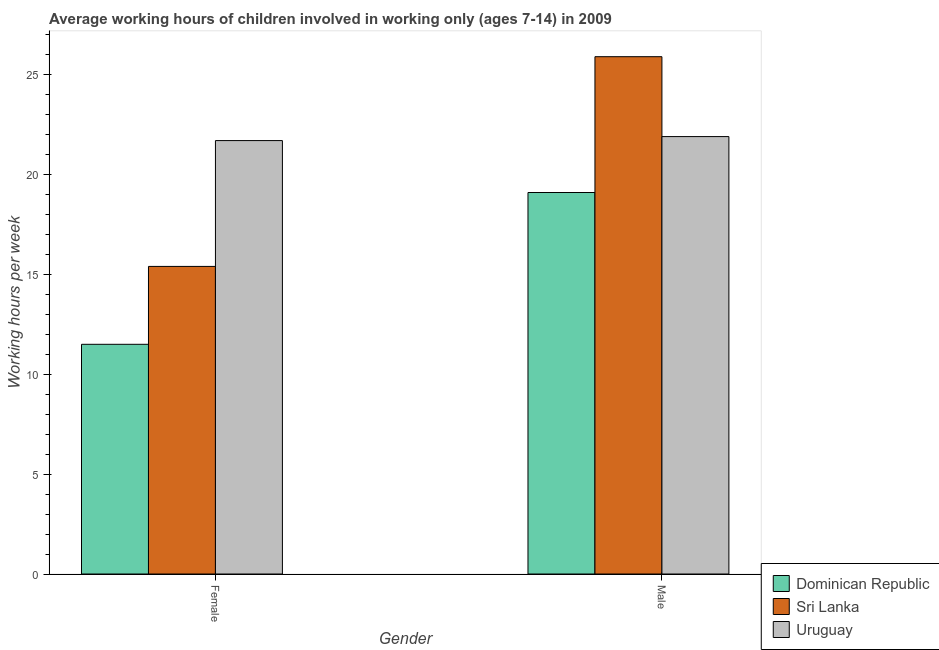How many different coloured bars are there?
Your answer should be very brief. 3. How many groups of bars are there?
Make the answer very short. 2. Are the number of bars per tick equal to the number of legend labels?
Make the answer very short. Yes. How many bars are there on the 1st tick from the right?
Offer a terse response. 3. What is the label of the 2nd group of bars from the left?
Give a very brief answer. Male. Across all countries, what is the maximum average working hour of male children?
Your response must be concise. 25.9. In which country was the average working hour of female children maximum?
Offer a terse response. Uruguay. In which country was the average working hour of male children minimum?
Give a very brief answer. Dominican Republic. What is the total average working hour of male children in the graph?
Provide a succinct answer. 66.9. What is the difference between the average working hour of male children in Uruguay and that in Sri Lanka?
Make the answer very short. -4. What is the difference between the average working hour of female children in Sri Lanka and the average working hour of male children in Uruguay?
Offer a terse response. -6.5. What is the average average working hour of male children per country?
Keep it short and to the point. 22.3. What is the difference between the average working hour of female children and average working hour of male children in Dominican Republic?
Make the answer very short. -7.6. In how many countries, is the average working hour of male children greater than 15 hours?
Offer a very short reply. 3. What is the ratio of the average working hour of female children in Uruguay to that in Sri Lanka?
Provide a succinct answer. 1.41. Is the average working hour of male children in Uruguay less than that in Dominican Republic?
Offer a terse response. No. What does the 3rd bar from the left in Female represents?
Your answer should be very brief. Uruguay. What does the 2nd bar from the right in Female represents?
Offer a very short reply. Sri Lanka. How many bars are there?
Make the answer very short. 6. How many countries are there in the graph?
Your answer should be very brief. 3. What is the difference between two consecutive major ticks on the Y-axis?
Keep it short and to the point. 5. Are the values on the major ticks of Y-axis written in scientific E-notation?
Provide a short and direct response. No. Does the graph contain grids?
Keep it short and to the point. No. Where does the legend appear in the graph?
Make the answer very short. Bottom right. How many legend labels are there?
Your answer should be compact. 3. How are the legend labels stacked?
Your answer should be compact. Vertical. What is the title of the graph?
Your answer should be very brief. Average working hours of children involved in working only (ages 7-14) in 2009. What is the label or title of the Y-axis?
Ensure brevity in your answer.  Working hours per week. What is the Working hours per week in Dominican Republic in Female?
Make the answer very short. 11.5. What is the Working hours per week of Sri Lanka in Female?
Offer a very short reply. 15.4. What is the Working hours per week of Uruguay in Female?
Provide a short and direct response. 21.7. What is the Working hours per week of Dominican Republic in Male?
Your answer should be compact. 19.1. What is the Working hours per week in Sri Lanka in Male?
Offer a very short reply. 25.9. What is the Working hours per week in Uruguay in Male?
Your answer should be compact. 21.9. Across all Gender, what is the maximum Working hours per week of Dominican Republic?
Offer a very short reply. 19.1. Across all Gender, what is the maximum Working hours per week in Sri Lanka?
Offer a very short reply. 25.9. Across all Gender, what is the maximum Working hours per week in Uruguay?
Your response must be concise. 21.9. Across all Gender, what is the minimum Working hours per week of Sri Lanka?
Your response must be concise. 15.4. Across all Gender, what is the minimum Working hours per week in Uruguay?
Make the answer very short. 21.7. What is the total Working hours per week in Dominican Republic in the graph?
Provide a short and direct response. 30.6. What is the total Working hours per week of Sri Lanka in the graph?
Offer a very short reply. 41.3. What is the total Working hours per week of Uruguay in the graph?
Offer a very short reply. 43.6. What is the difference between the Working hours per week in Dominican Republic in Female and that in Male?
Provide a short and direct response. -7.6. What is the difference between the Working hours per week in Sri Lanka in Female and that in Male?
Provide a succinct answer. -10.5. What is the difference between the Working hours per week of Dominican Republic in Female and the Working hours per week of Sri Lanka in Male?
Your response must be concise. -14.4. What is the difference between the Working hours per week of Dominican Republic in Female and the Working hours per week of Uruguay in Male?
Offer a very short reply. -10.4. What is the average Working hours per week of Dominican Republic per Gender?
Provide a short and direct response. 15.3. What is the average Working hours per week of Sri Lanka per Gender?
Offer a terse response. 20.65. What is the average Working hours per week of Uruguay per Gender?
Make the answer very short. 21.8. What is the difference between the Working hours per week of Dominican Republic and Working hours per week of Uruguay in Female?
Your answer should be compact. -10.2. What is the difference between the Working hours per week in Sri Lanka and Working hours per week in Uruguay in Female?
Provide a short and direct response. -6.3. What is the difference between the Working hours per week in Dominican Republic and Working hours per week in Sri Lanka in Male?
Offer a very short reply. -6.8. What is the difference between the Working hours per week of Dominican Republic and Working hours per week of Uruguay in Male?
Ensure brevity in your answer.  -2.8. What is the difference between the Working hours per week in Sri Lanka and Working hours per week in Uruguay in Male?
Your response must be concise. 4. What is the ratio of the Working hours per week in Dominican Republic in Female to that in Male?
Your answer should be compact. 0.6. What is the ratio of the Working hours per week of Sri Lanka in Female to that in Male?
Ensure brevity in your answer.  0.59. What is the ratio of the Working hours per week in Uruguay in Female to that in Male?
Offer a very short reply. 0.99. What is the difference between the highest and the second highest Working hours per week of Uruguay?
Offer a very short reply. 0.2. What is the difference between the highest and the lowest Working hours per week in Sri Lanka?
Offer a terse response. 10.5. 